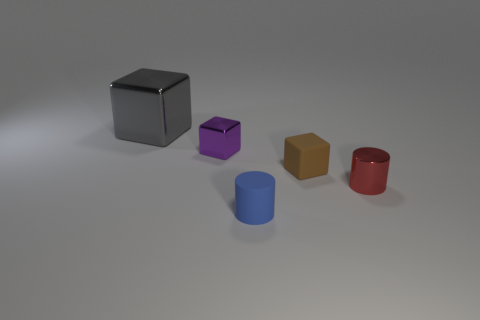Is there any other thing that has the same size as the gray shiny object?
Your answer should be very brief. No. Is the number of small purple blocks that are on the left side of the gray shiny cube greater than the number of gray cubes that are to the right of the red thing?
Your response must be concise. No. What number of cubes are shiny objects or small purple metal things?
Your answer should be very brief. 2. Does the object in front of the small red shiny thing have the same shape as the small purple shiny object?
Give a very brief answer. No. What color is the large block?
Offer a terse response. Gray. What color is the other small metallic thing that is the same shape as the gray metallic thing?
Keep it short and to the point. Purple. What number of other tiny blue things have the same shape as the blue object?
Offer a very short reply. 0. What number of things are large cyan spheres or objects that are behind the small brown rubber cube?
Offer a terse response. 2. What is the size of the object that is right of the blue rubber cylinder and behind the tiny shiny cylinder?
Your answer should be compact. Small. There is a tiny purple block; are there any tiny rubber cylinders to the right of it?
Ensure brevity in your answer.  Yes. 